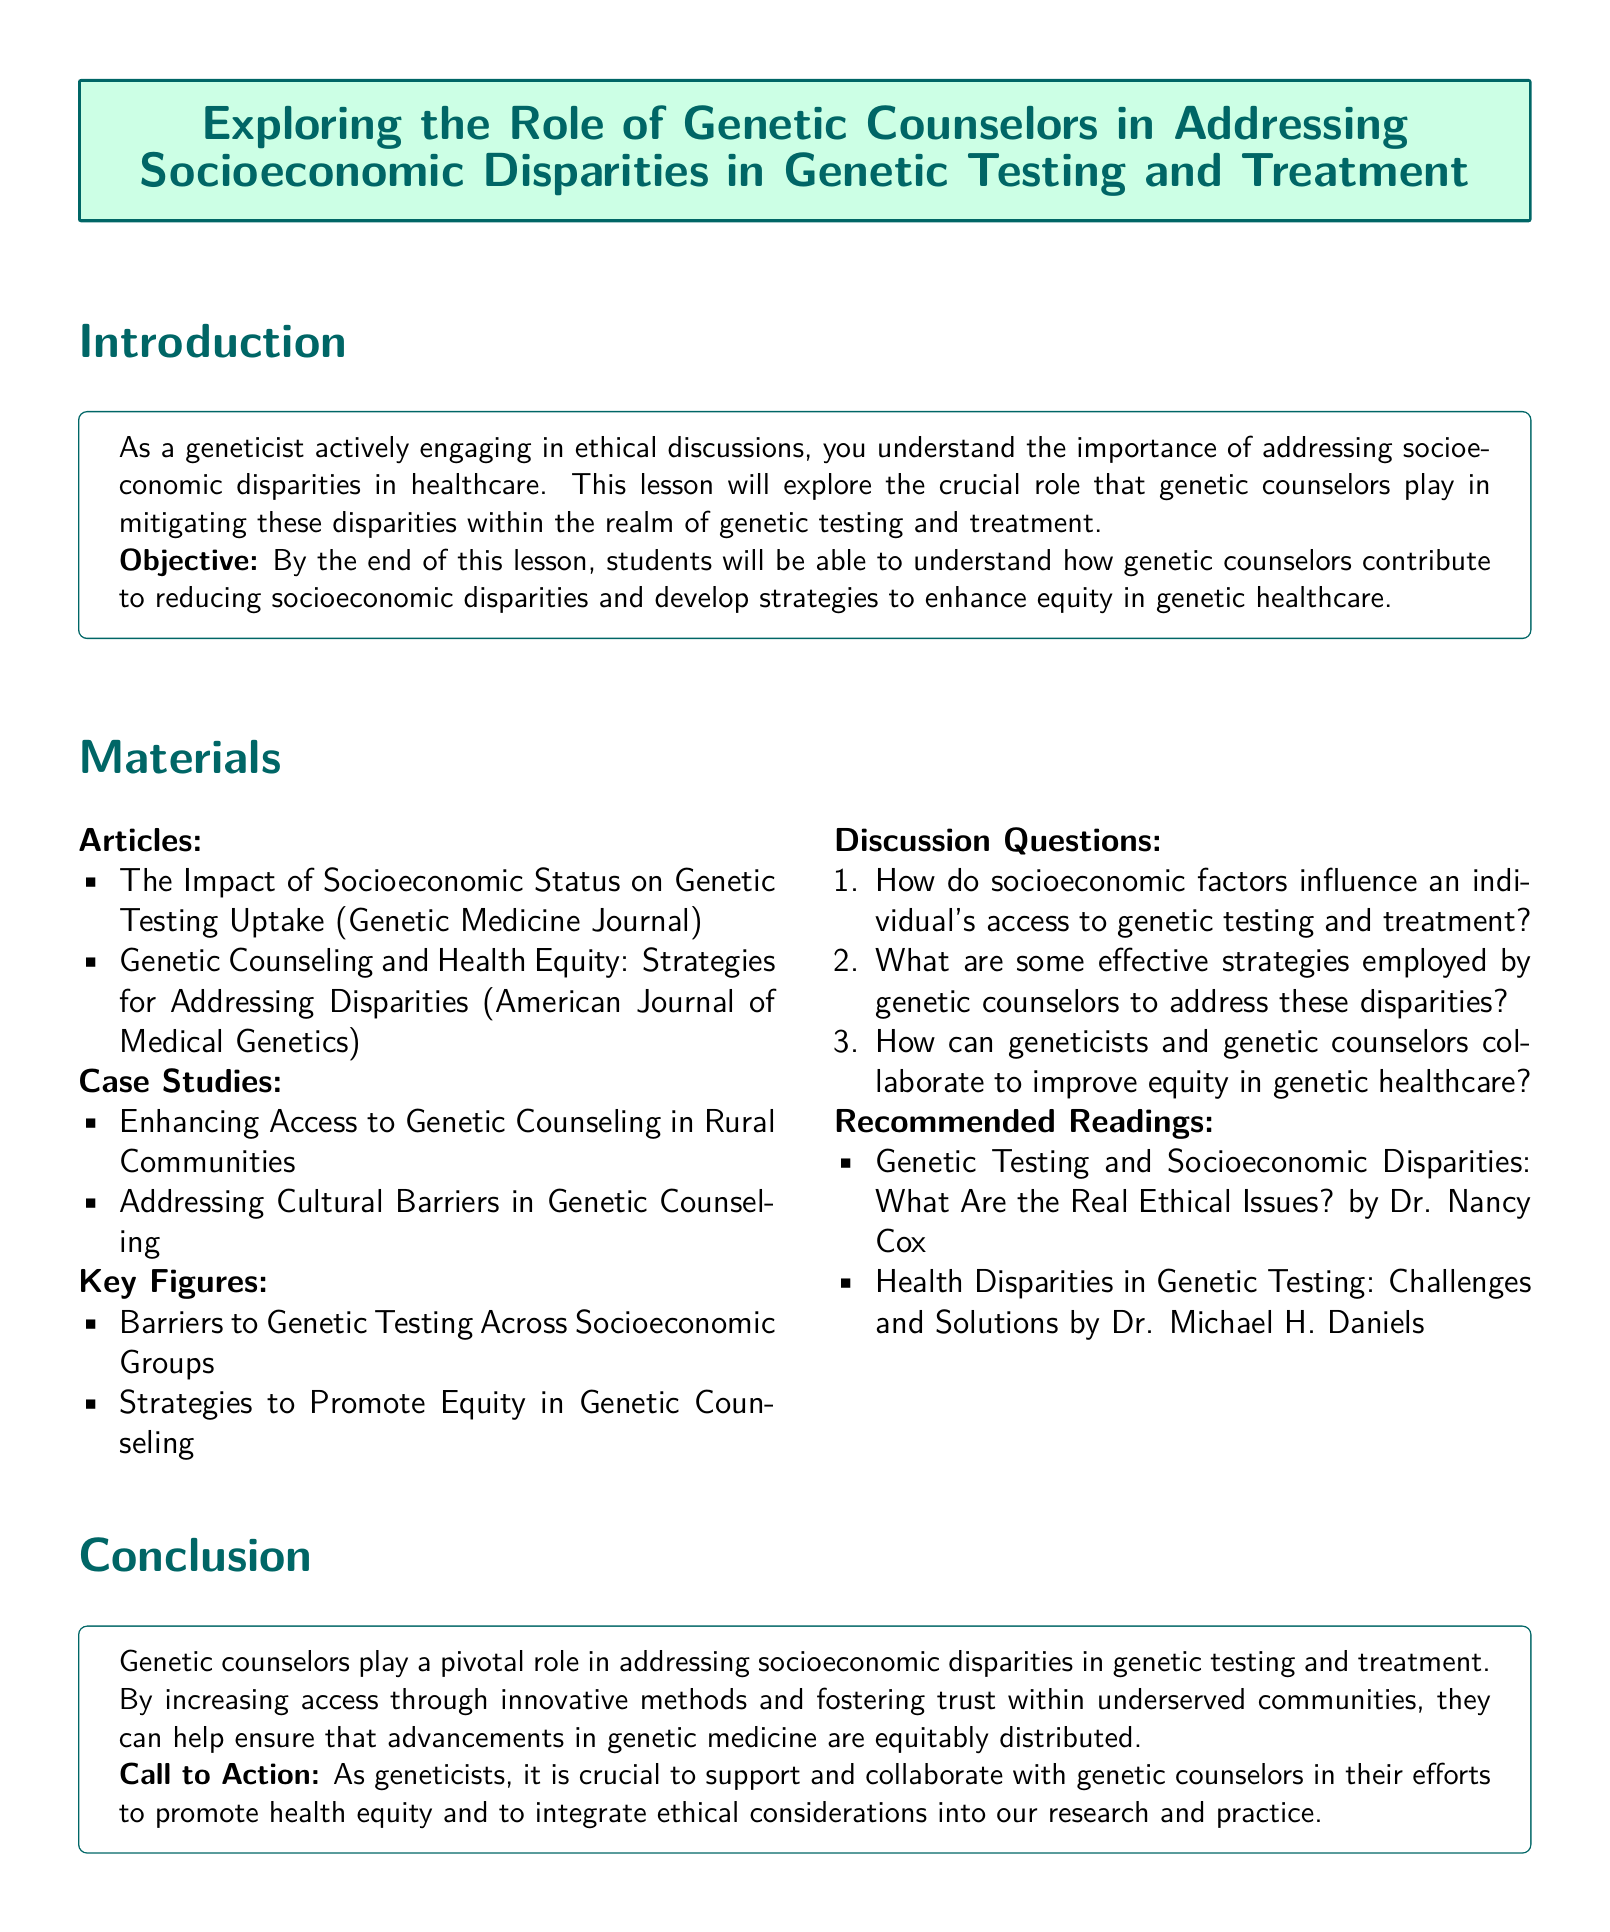What is the title of the lesson plan? The title of the lesson plan, as stated in the document, is given in the prominent box at the beginning.
Answer: Exploring the Role of Genetic Counselors in Addressing Socioeconomic Disparities in Genetic Testing and Treatment What is the main objective of the lesson? The objective outlines what students will learn by the end of the lesson regarding the role of genetic counselors.
Answer: Understand how genetic counselors contribute to reducing socioeconomic disparities and develop strategies to enhance equity in genetic healthcare Name two articles included in the materials section. The materials include a list of articles that are relevant to the lesson's topics.
Answer: The Impact of Socioeconomic Status on Genetic Testing Uptake, Genetic Counseling and Health Equity: Strategies for Addressing Disparities What are the barriers to genetic testing discussed? The document lists key figures focusing on disparities in genetic healthcare, indicating what aspects to look at.
Answer: Barriers to Genetic Testing Across Socioeconomic Groups How can geneticists and genetic counselors work together? The lesson plan includes discussion questions that encourage exploration of collaboration between these professionals.
Answer: Improve equity in genetic healthcare What is a case study mentioned in the lesson plan? The lesson plan provides examples of case studies that deal with real-world scenarios relevant to the lesson.
Answer: Enhancing Access to Genetic Counseling in Rural Communities 